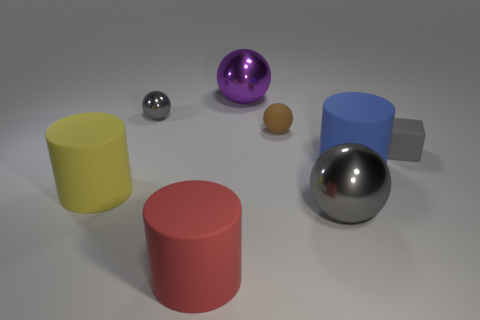Add 1 brown balls. How many objects exist? 9 Subtract all cylinders. How many objects are left? 5 Add 4 tiny objects. How many tiny objects are left? 7 Add 4 large blue objects. How many large blue objects exist? 5 Subtract 0 brown cubes. How many objects are left? 8 Subtract all small purple things. Subtract all large blue matte cylinders. How many objects are left? 7 